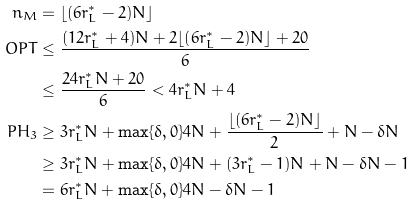Convert formula to latex. <formula><loc_0><loc_0><loc_500><loc_500>n _ { M } & = \lfloor ( 6 r _ { L } ^ { * } - 2 ) N \rfloor \\ O P T & \leq \frac { ( 1 2 r _ { L } ^ { * } + 4 ) N + 2 \lfloor ( 6 r _ { L } ^ { * } - 2 ) N \rfloor + 2 0 } { 6 } \\ & \leq \frac { 2 4 r _ { L } ^ { * } N + 2 0 } { 6 } < 4 r _ { L } ^ { * } N + 4 \\ P H _ { 3 } & \geq 3 r _ { L } ^ { * } N + \max \{ \delta , 0 \} 4 N + \frac { \lfloor ( 6 r _ { L } ^ { * } - 2 ) N \rfloor } { 2 } + N - \delta N \\ & \geq 3 r _ { L } ^ { * } N + \max \{ \delta , 0 \} 4 N + ( 3 r _ { L } ^ { * } - 1 ) N + N - \delta N - 1 \\ & = 6 r _ { L } ^ { * } N + \max \{ \delta , 0 \} 4 N - \delta N - 1</formula> 